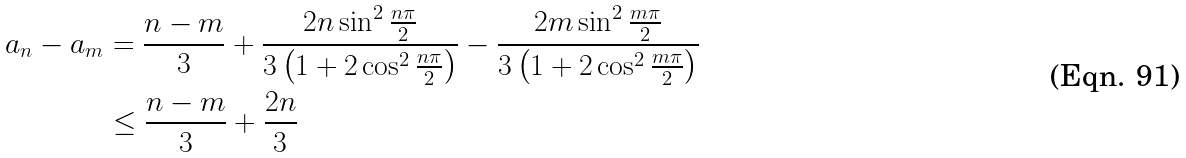Convert formula to latex. <formula><loc_0><loc_0><loc_500><loc_500>a _ { n } - a _ { m } & = \frac { n - m } { 3 } + \frac { 2 n \sin ^ { 2 } \frac { n \pi } { 2 } } { 3 \left ( 1 + 2 \cos ^ { 2 } \frac { n \pi } { 2 } \right ) } - \frac { 2 m \sin ^ { 2 } \frac { m \pi } { 2 } } { 3 \left ( 1 + 2 \cos ^ { 2 } \frac { m \pi } { 2 } \right ) } \\ & \leq \frac { n - m } { 3 } + \frac { 2 n } { 3 }</formula> 